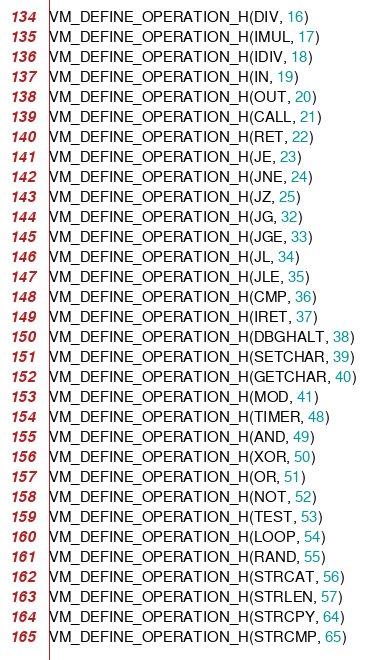Convert code to text. <code><loc_0><loc_0><loc_500><loc_500><_C_>VM_DEFINE_OPERATION_H(DIV, 16)
VM_DEFINE_OPERATION_H(IMUL, 17)
VM_DEFINE_OPERATION_H(IDIV, 18)
VM_DEFINE_OPERATION_H(IN, 19)
VM_DEFINE_OPERATION_H(OUT, 20)
VM_DEFINE_OPERATION_H(CALL, 21)
VM_DEFINE_OPERATION_H(RET, 22)
VM_DEFINE_OPERATION_H(JE, 23)
VM_DEFINE_OPERATION_H(JNE, 24)
VM_DEFINE_OPERATION_H(JZ, 25)
VM_DEFINE_OPERATION_H(JG, 32)
VM_DEFINE_OPERATION_H(JGE, 33)
VM_DEFINE_OPERATION_H(JL, 34)
VM_DEFINE_OPERATION_H(JLE, 35)
VM_DEFINE_OPERATION_H(CMP, 36)
VM_DEFINE_OPERATION_H(IRET, 37)
VM_DEFINE_OPERATION_H(DBGHALT, 38)
VM_DEFINE_OPERATION_H(SETCHAR, 39)
VM_DEFINE_OPERATION_H(GETCHAR, 40)
VM_DEFINE_OPERATION_H(MOD, 41)
VM_DEFINE_OPERATION_H(TIMER, 48)
VM_DEFINE_OPERATION_H(AND, 49)
VM_DEFINE_OPERATION_H(XOR, 50)
VM_DEFINE_OPERATION_H(OR, 51)
VM_DEFINE_OPERATION_H(NOT, 52)
VM_DEFINE_OPERATION_H(TEST, 53)
VM_DEFINE_OPERATION_H(LOOP, 54)
VM_DEFINE_OPERATION_H(RAND, 55)
VM_DEFINE_OPERATION_H(STRCAT, 56)
VM_DEFINE_OPERATION_H(STRLEN, 57)
VM_DEFINE_OPERATION_H(STRCPY, 64)
VM_DEFINE_OPERATION_H(STRCMP, 65)

</code> 